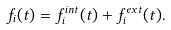Convert formula to latex. <formula><loc_0><loc_0><loc_500><loc_500>f _ { i } ( t ) = f _ { i } ^ { i n t } ( t ) + f _ { i } ^ { e x t } ( t ) .</formula> 